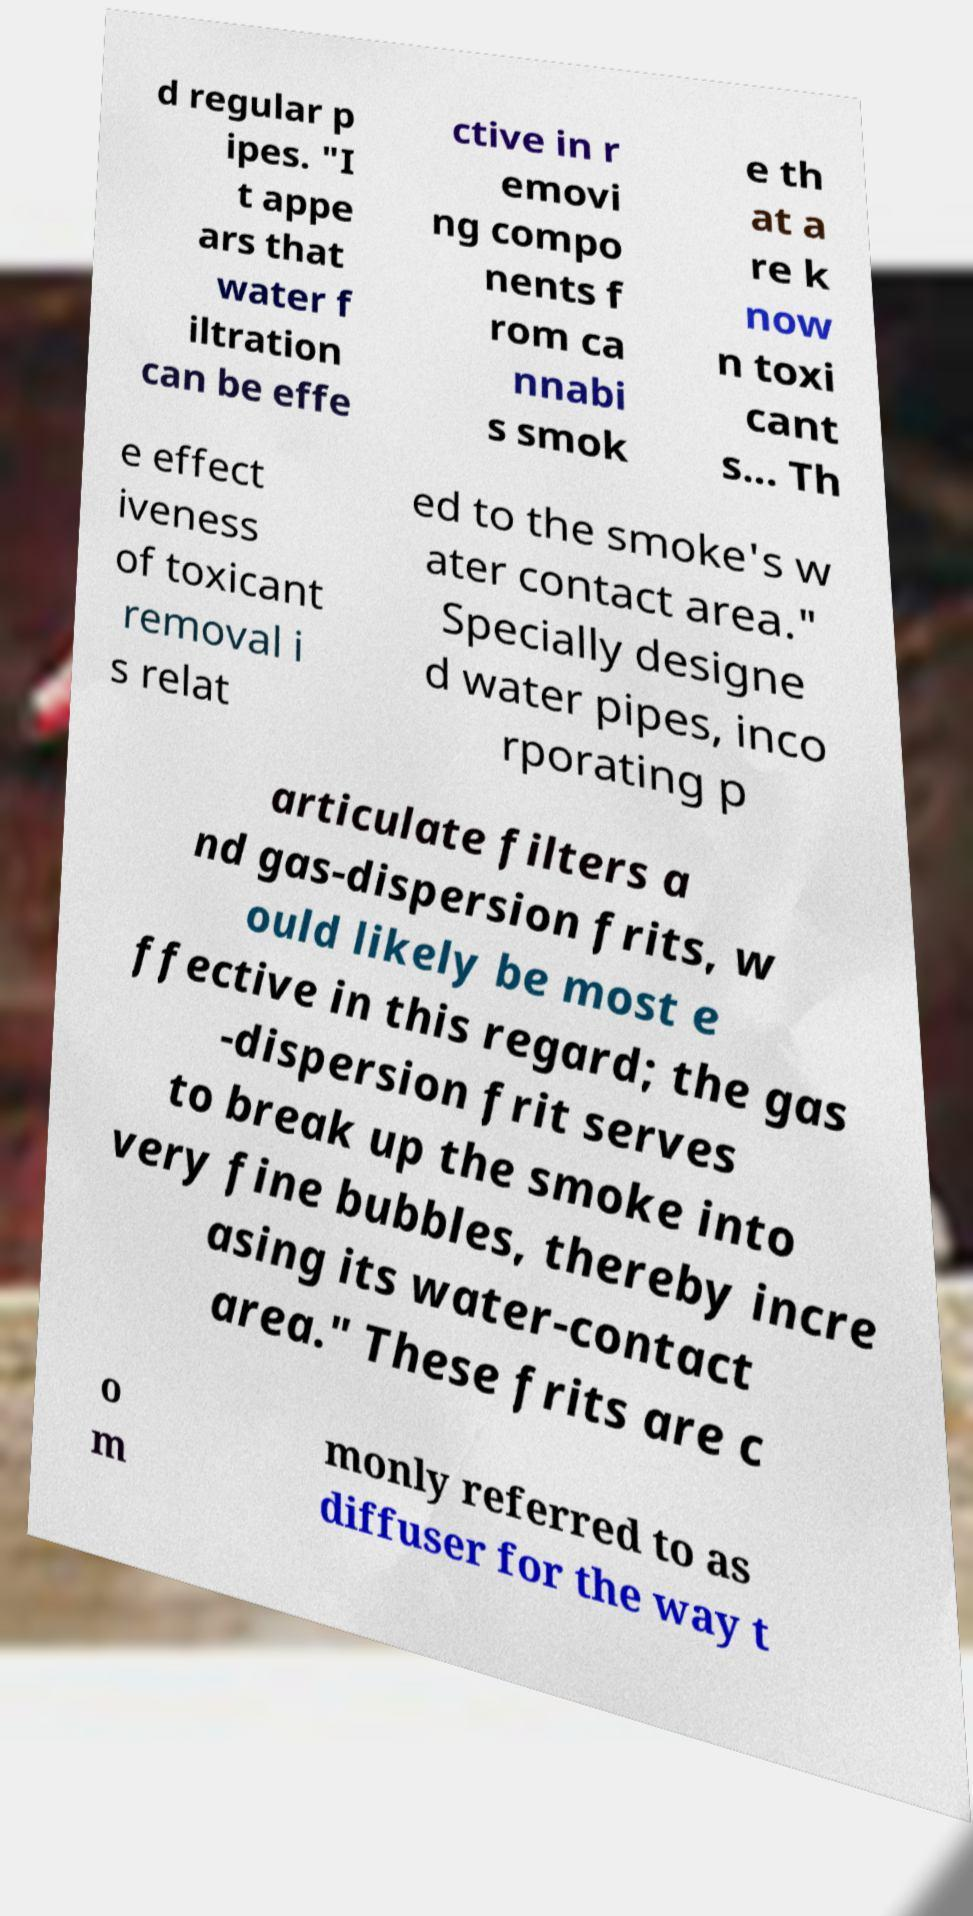Please identify and transcribe the text found in this image. d regular p ipes. "I t appe ars that water f iltration can be effe ctive in r emovi ng compo nents f rom ca nnabi s smok e th at a re k now n toxi cant s... Th e effect iveness of toxicant removal i s relat ed to the smoke's w ater contact area." Specially designe d water pipes, inco rporating p articulate filters a nd gas-dispersion frits, w ould likely be most e ffective in this regard; the gas -dispersion frit serves to break up the smoke into very fine bubbles, thereby incre asing its water-contact area." These frits are c o m monly referred to as diffuser for the way t 